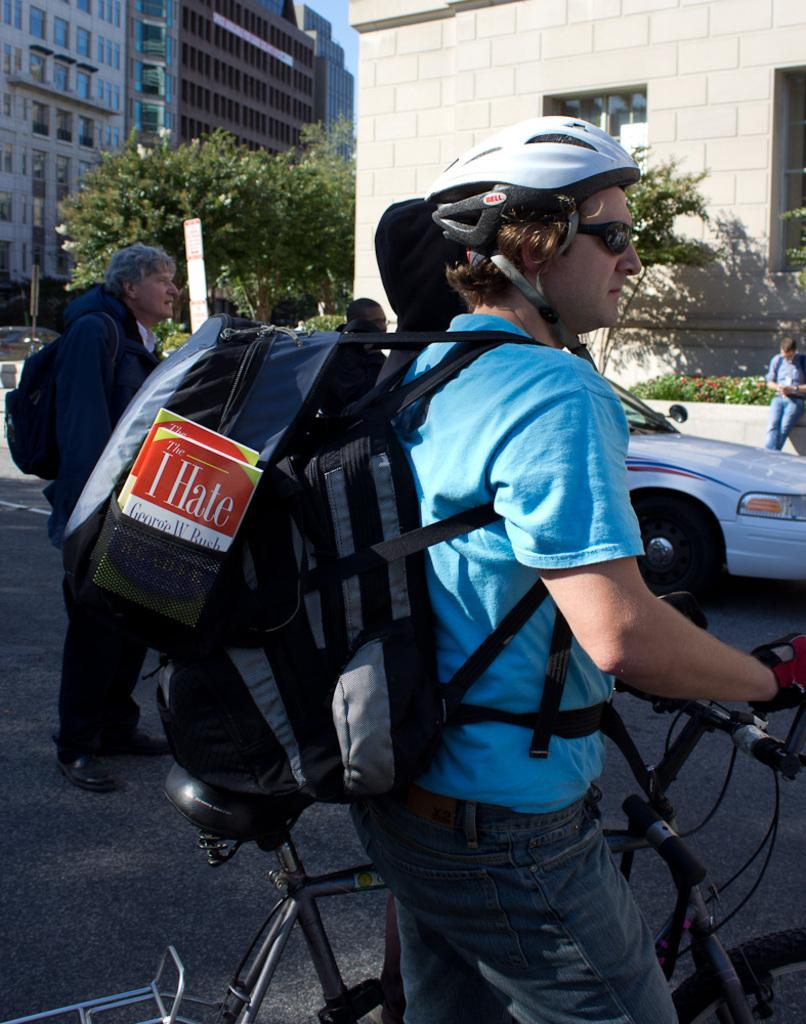Provide a one-sentence caption for the provided image. A man rides a bicycle with an I Hate book by George W. Bush in his backpack. 